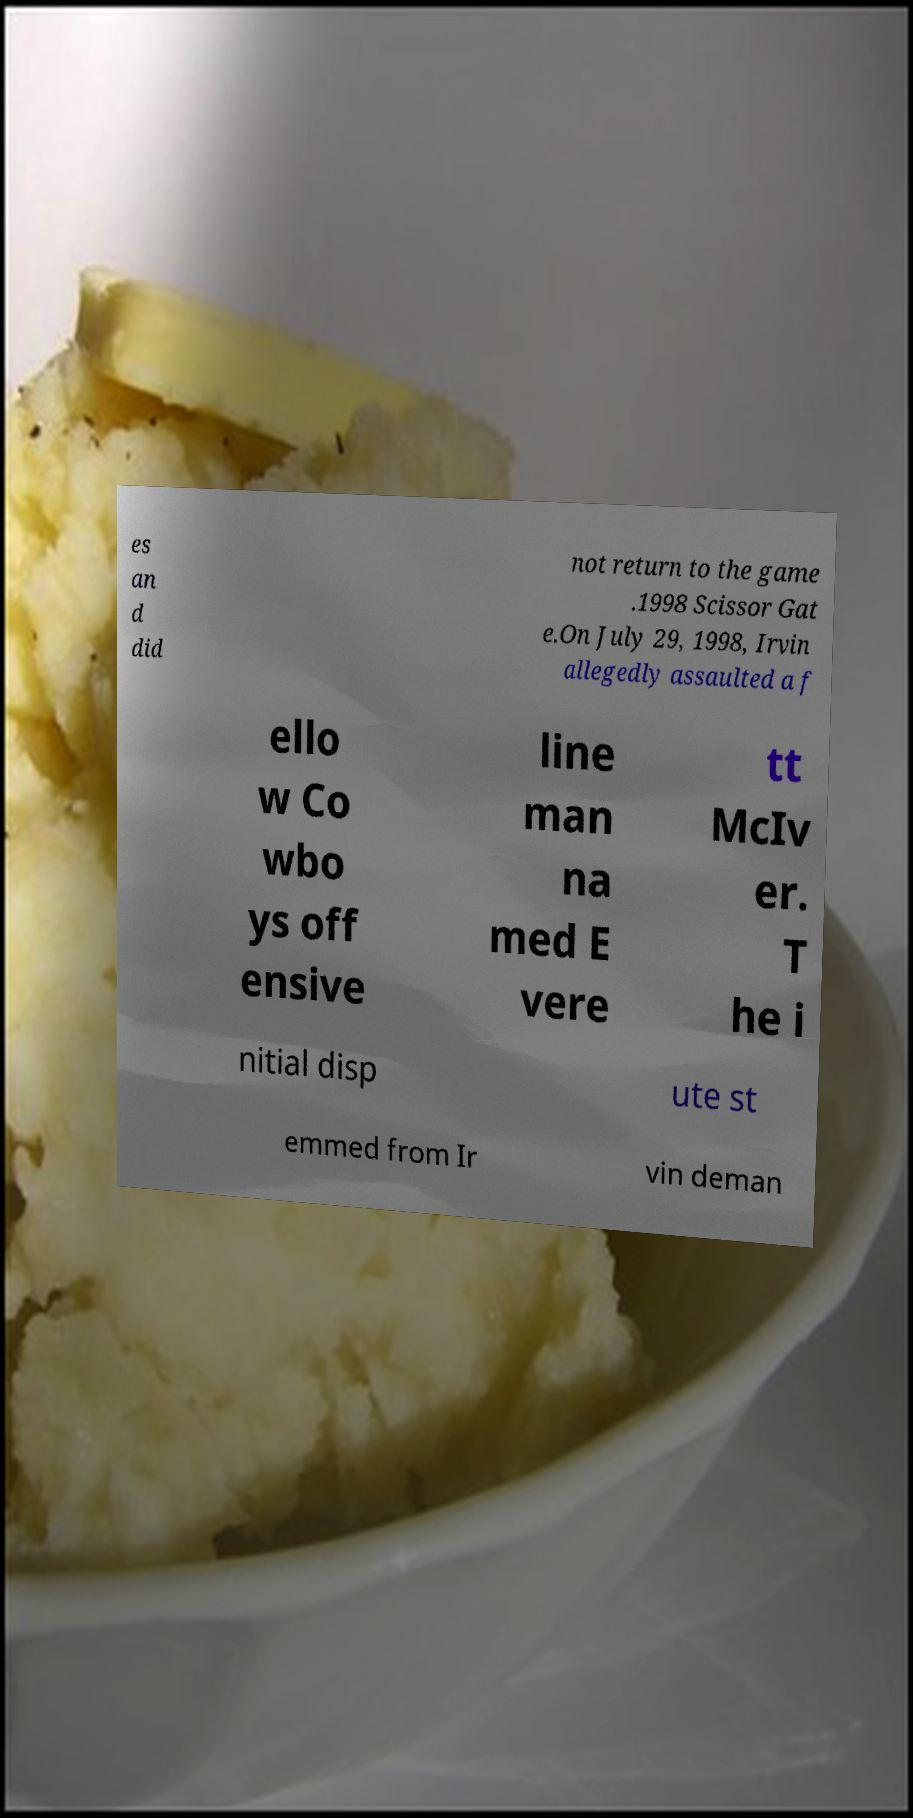What messages or text are displayed in this image? I need them in a readable, typed format. es an d did not return to the game .1998 Scissor Gat e.On July 29, 1998, Irvin allegedly assaulted a f ello w Co wbo ys off ensive line man na med E vere tt McIv er. T he i nitial disp ute st emmed from Ir vin deman 